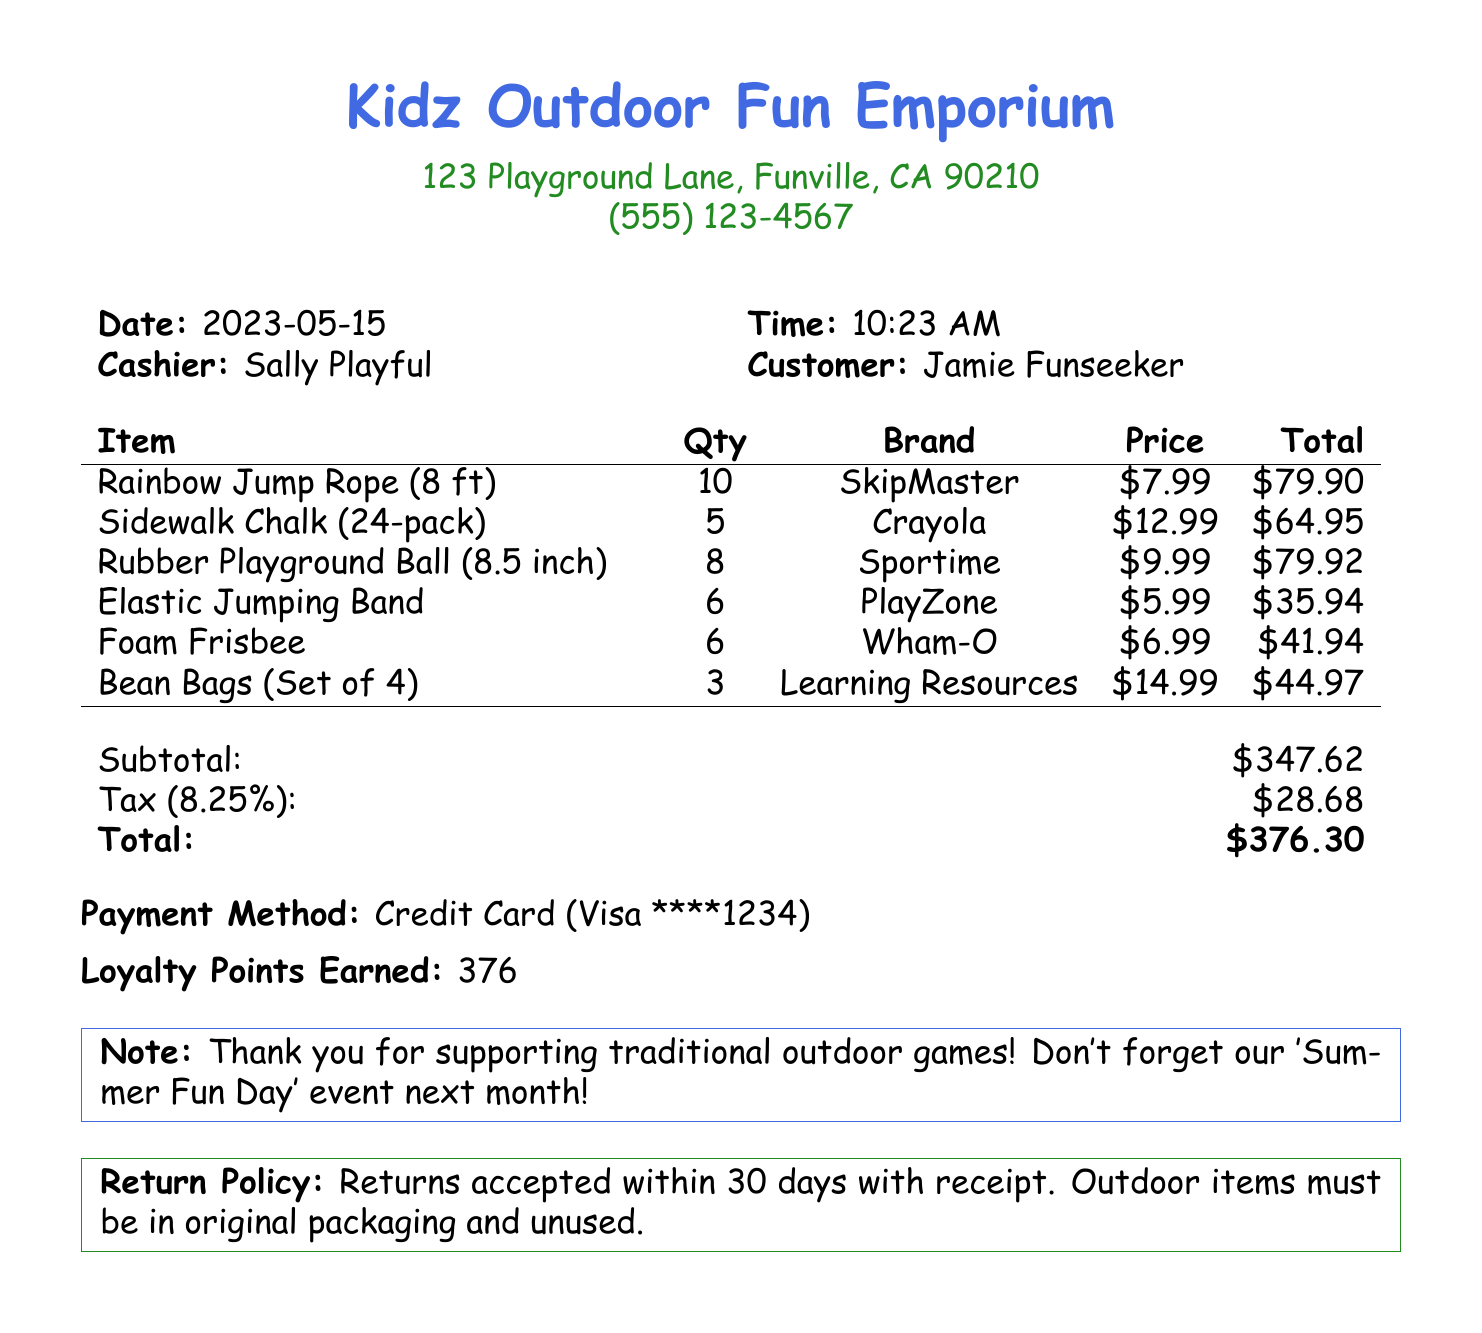What is the store name? The store name is provided at the top of the document.
Answer: Kidz Outdoor Fun Emporium What is the date of the purchase? The date is indicated next to the 'Date:' label in the document.
Answer: 2023-05-15 How many Rubber Playground Balls were purchased? The quantity is listed under the item details for Rubber Playground Balls.
Answer: 8 What is the subtotal amount? The subtotal is noted in the financial summary section of the receipt.
Answer: $347.62 Who was the cashier for this transaction? The cashier's name is mentioned next to the 'Cashier:' label in the document.
Answer: Sally Playful What is the tax rate applied to the purchase? The tax rate is specifically mentioned in the tax section of the receipt.
Answer: 8.25% What is the total amount paid? The total amount is highlighted in the final financial summary of the document.
Answer: $376.30 How many loyalty points were earned from this purchase? The loyalty points are listed in another section, indicating the reward for this transaction.
Answer: 376 What is the return policy for the outdoor items? The return policy is mentioned at the bottom of the receipt explaining the terms for returns.
Answer: Returns accepted within 30 days with receipt 